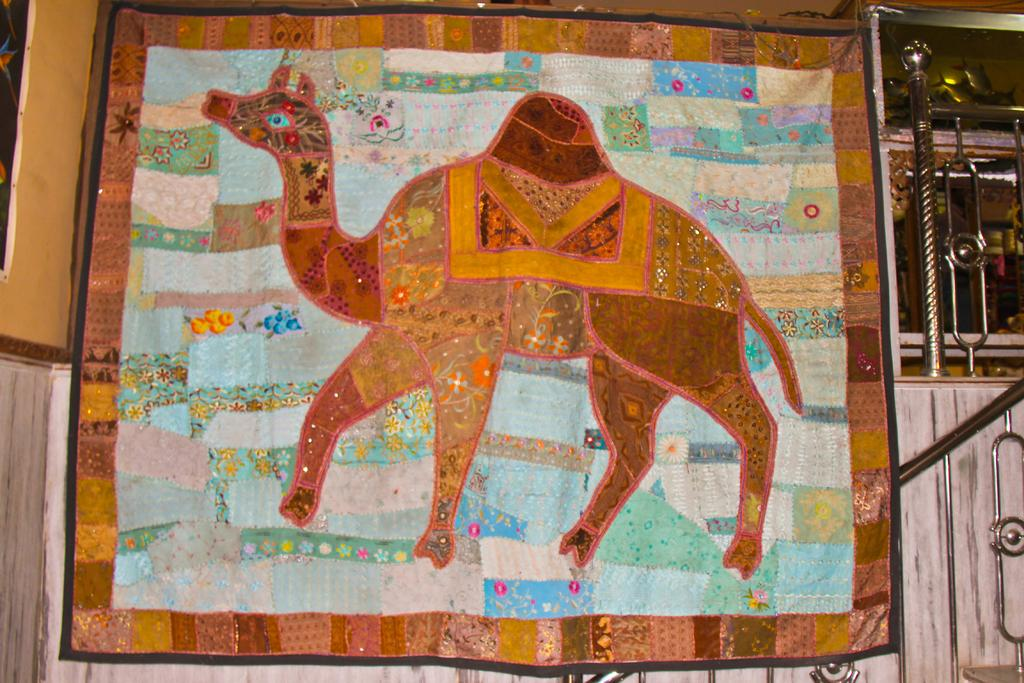What is displayed on the banner in the image? The banner features an animal. What type of structure can be seen in the image? There is railing, rods, and a wall visible in the image. What material is present in the image that is transparent or translucent? There is glass in the image. What type of marble is used to create the animal on the banner? There is no marble present in the image; the banner features an animal, but it is not made of marble. How does the paste hold the banner to the wall in the image? There is no mention of paste in the image; the banner is not described as being attached to the wall with any adhesive. Can you see any sheep in the image? There are no sheep present in the image. 